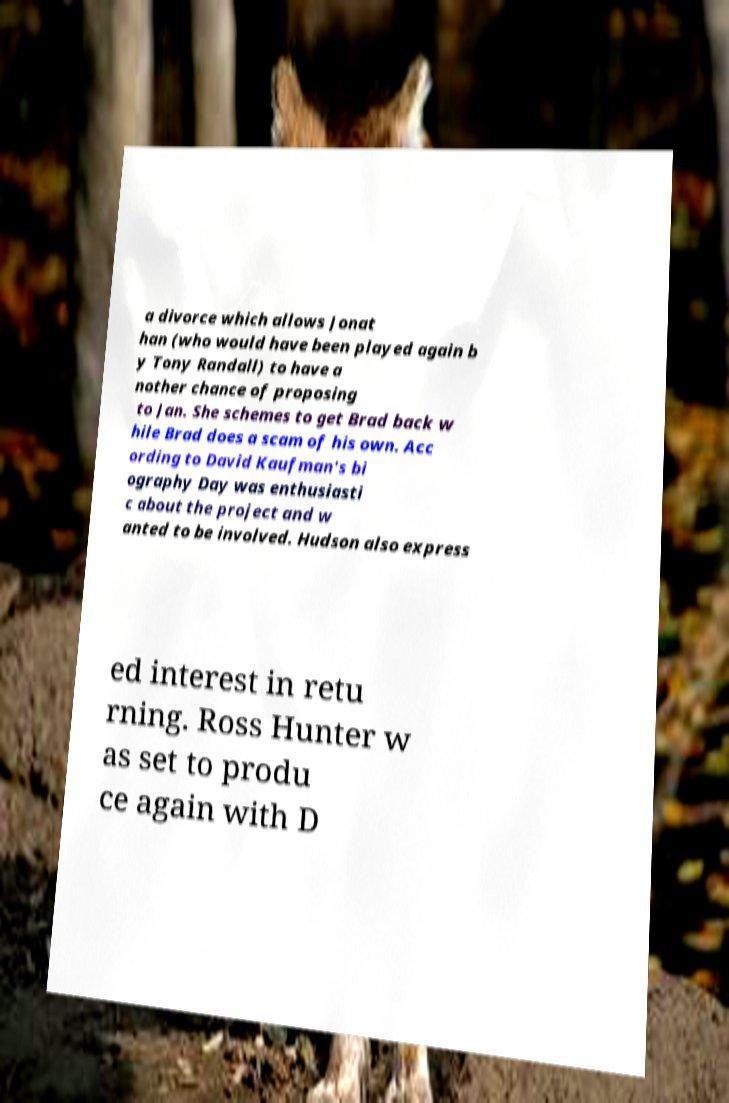Please identify and transcribe the text found in this image. a divorce which allows Jonat han (who would have been played again b y Tony Randall) to have a nother chance of proposing to Jan. She schemes to get Brad back w hile Brad does a scam of his own. Acc ording to David Kaufman's bi ography Day was enthusiasti c about the project and w anted to be involved. Hudson also express ed interest in retu rning. Ross Hunter w as set to produ ce again with D 